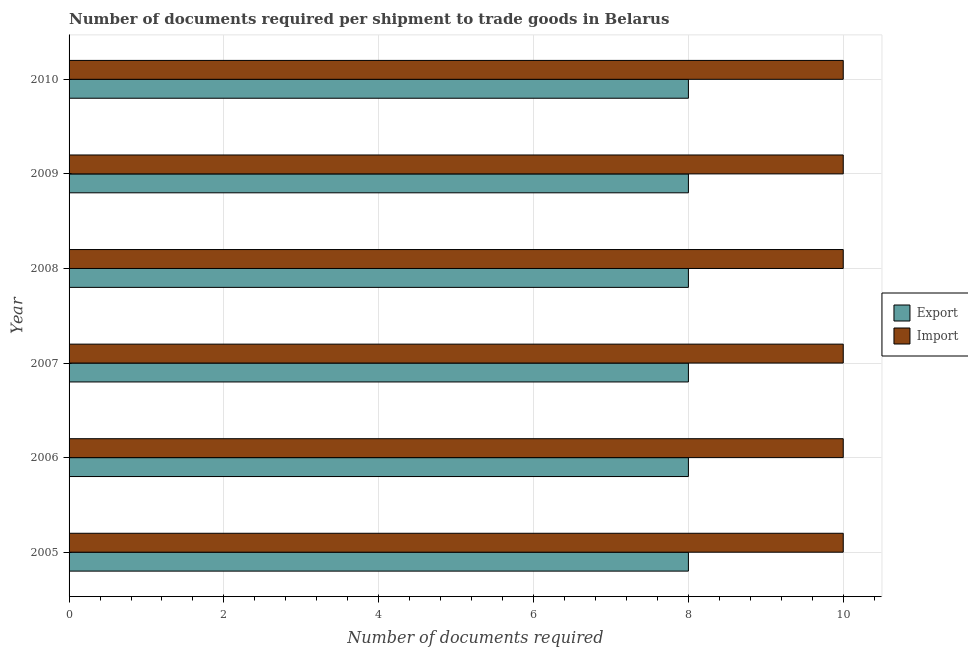How many different coloured bars are there?
Your response must be concise. 2. How many groups of bars are there?
Provide a short and direct response. 6. Are the number of bars on each tick of the Y-axis equal?
Give a very brief answer. Yes. How many bars are there on the 1st tick from the top?
Provide a short and direct response. 2. How many bars are there on the 2nd tick from the bottom?
Your response must be concise. 2. What is the label of the 4th group of bars from the top?
Provide a short and direct response. 2007. What is the number of documents required to import goods in 2009?
Offer a terse response. 10. Across all years, what is the maximum number of documents required to import goods?
Make the answer very short. 10. Across all years, what is the minimum number of documents required to import goods?
Keep it short and to the point. 10. In which year was the number of documents required to import goods maximum?
Provide a succinct answer. 2005. In which year was the number of documents required to export goods minimum?
Your answer should be compact. 2005. What is the total number of documents required to export goods in the graph?
Your answer should be compact. 48. What is the difference between the number of documents required to import goods in 2007 and that in 2009?
Provide a short and direct response. 0. What is the difference between the number of documents required to import goods in 2009 and the number of documents required to export goods in 2010?
Ensure brevity in your answer.  2. In the year 2009, what is the difference between the number of documents required to export goods and number of documents required to import goods?
Your answer should be very brief. -2. What is the ratio of the number of documents required to import goods in 2008 to that in 2009?
Offer a very short reply. 1. In how many years, is the number of documents required to export goods greater than the average number of documents required to export goods taken over all years?
Provide a succinct answer. 0. What does the 2nd bar from the top in 2008 represents?
Make the answer very short. Export. What does the 2nd bar from the bottom in 2010 represents?
Offer a very short reply. Import. How many bars are there?
Provide a succinct answer. 12. How many years are there in the graph?
Provide a short and direct response. 6. Are the values on the major ticks of X-axis written in scientific E-notation?
Provide a short and direct response. No. Does the graph contain any zero values?
Keep it short and to the point. No. How many legend labels are there?
Provide a short and direct response. 2. How are the legend labels stacked?
Your response must be concise. Vertical. What is the title of the graph?
Give a very brief answer. Number of documents required per shipment to trade goods in Belarus. Does "Pregnant women" appear as one of the legend labels in the graph?
Your response must be concise. No. What is the label or title of the X-axis?
Ensure brevity in your answer.  Number of documents required. What is the label or title of the Y-axis?
Make the answer very short. Year. What is the Number of documents required in Export in 2005?
Offer a terse response. 8. What is the Number of documents required in Import in 2005?
Your answer should be compact. 10. What is the Number of documents required in Export in 2007?
Offer a very short reply. 8. What is the Number of documents required in Import in 2008?
Provide a succinct answer. 10. What is the Number of documents required of Export in 2009?
Give a very brief answer. 8. What is the Number of documents required of Import in 2009?
Your answer should be very brief. 10. Across all years, what is the maximum Number of documents required in Export?
Offer a terse response. 8. Across all years, what is the minimum Number of documents required in Import?
Offer a terse response. 10. What is the total Number of documents required of Export in the graph?
Provide a short and direct response. 48. What is the difference between the Number of documents required of Export in 2005 and that in 2006?
Ensure brevity in your answer.  0. What is the difference between the Number of documents required in Export in 2005 and that in 2007?
Keep it short and to the point. 0. What is the difference between the Number of documents required in Import in 2005 and that in 2007?
Keep it short and to the point. 0. What is the difference between the Number of documents required in Import in 2005 and that in 2008?
Make the answer very short. 0. What is the difference between the Number of documents required of Import in 2005 and that in 2009?
Your answer should be very brief. 0. What is the difference between the Number of documents required in Export in 2006 and that in 2007?
Your answer should be very brief. 0. What is the difference between the Number of documents required in Import in 2006 and that in 2008?
Offer a terse response. 0. What is the difference between the Number of documents required of Import in 2006 and that in 2009?
Make the answer very short. 0. What is the difference between the Number of documents required in Export in 2006 and that in 2010?
Your answer should be very brief. 0. What is the difference between the Number of documents required of Import in 2006 and that in 2010?
Your answer should be very brief. 0. What is the difference between the Number of documents required of Import in 2007 and that in 2010?
Provide a succinct answer. 0. What is the difference between the Number of documents required in Export in 2008 and that in 2009?
Offer a terse response. 0. What is the difference between the Number of documents required in Import in 2008 and that in 2009?
Ensure brevity in your answer.  0. What is the difference between the Number of documents required in Import in 2008 and that in 2010?
Make the answer very short. 0. What is the difference between the Number of documents required of Export in 2009 and that in 2010?
Your answer should be compact. 0. What is the difference between the Number of documents required of Import in 2009 and that in 2010?
Keep it short and to the point. 0. What is the difference between the Number of documents required in Export in 2005 and the Number of documents required in Import in 2006?
Provide a short and direct response. -2. What is the difference between the Number of documents required of Export in 2006 and the Number of documents required of Import in 2008?
Make the answer very short. -2. What is the difference between the Number of documents required in Export in 2006 and the Number of documents required in Import in 2010?
Make the answer very short. -2. What is the difference between the Number of documents required in Export in 2007 and the Number of documents required in Import in 2008?
Offer a very short reply. -2. What is the difference between the Number of documents required in Export in 2007 and the Number of documents required in Import in 2010?
Your response must be concise. -2. What is the difference between the Number of documents required in Export in 2008 and the Number of documents required in Import in 2009?
Your answer should be very brief. -2. What is the difference between the Number of documents required in Export in 2009 and the Number of documents required in Import in 2010?
Give a very brief answer. -2. In the year 2007, what is the difference between the Number of documents required of Export and Number of documents required of Import?
Your response must be concise. -2. In the year 2008, what is the difference between the Number of documents required of Export and Number of documents required of Import?
Make the answer very short. -2. What is the ratio of the Number of documents required of Export in 2005 to that in 2007?
Keep it short and to the point. 1. What is the ratio of the Number of documents required in Export in 2005 to that in 2009?
Ensure brevity in your answer.  1. What is the ratio of the Number of documents required in Import in 2005 to that in 2009?
Provide a succinct answer. 1. What is the ratio of the Number of documents required in Export in 2005 to that in 2010?
Your response must be concise. 1. What is the ratio of the Number of documents required in Import in 2006 to that in 2007?
Offer a terse response. 1. What is the ratio of the Number of documents required of Import in 2006 to that in 2008?
Offer a terse response. 1. What is the ratio of the Number of documents required of Export in 2006 to that in 2009?
Offer a terse response. 1. What is the ratio of the Number of documents required of Import in 2006 to that in 2009?
Your answer should be very brief. 1. What is the ratio of the Number of documents required of Import in 2006 to that in 2010?
Provide a short and direct response. 1. What is the ratio of the Number of documents required in Import in 2007 to that in 2008?
Ensure brevity in your answer.  1. What is the ratio of the Number of documents required of Export in 2007 to that in 2009?
Your answer should be compact. 1. What is the ratio of the Number of documents required of Export in 2007 to that in 2010?
Give a very brief answer. 1. What is the ratio of the Number of documents required in Export in 2008 to that in 2009?
Make the answer very short. 1. What is the ratio of the Number of documents required of Import in 2008 to that in 2009?
Your answer should be very brief. 1. What is the ratio of the Number of documents required in Export in 2008 to that in 2010?
Your answer should be very brief. 1. What is the ratio of the Number of documents required in Export in 2009 to that in 2010?
Provide a short and direct response. 1. What is the difference between the highest and the lowest Number of documents required in Import?
Offer a very short reply. 0. 